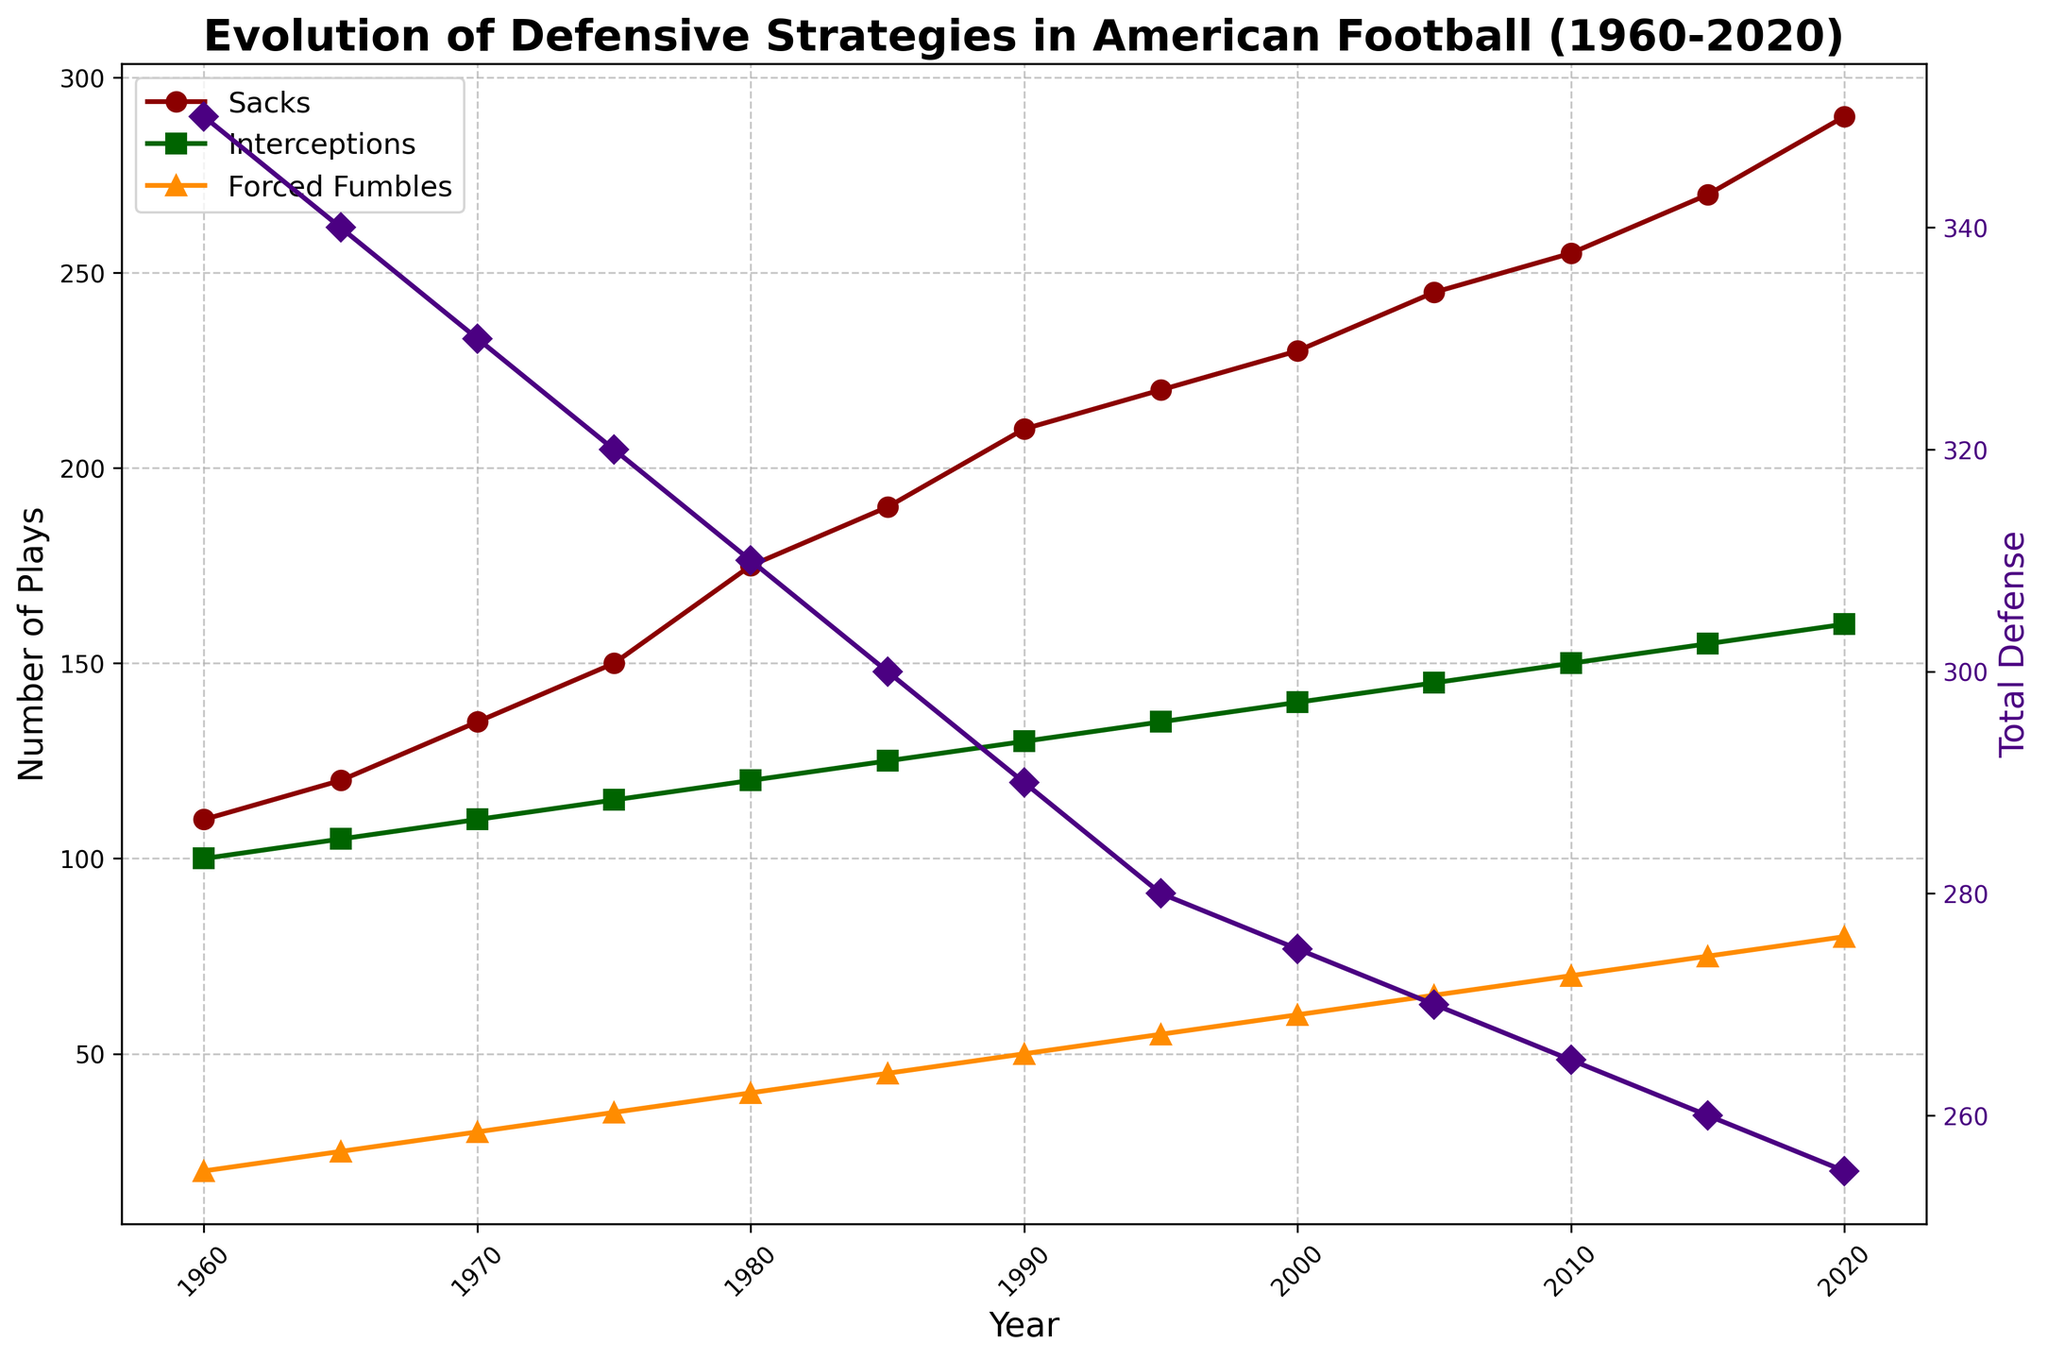What is the title of the figure? The title is displayed at the top of the figure in bold text. It provides an overview of what the figure represents.
Answer: Evolution of Defensive Strategies in American Football (1960-2020) What are the units of measurement on the y-axis? The y-axis labels indicate the units of measurement, which are displayed as 'Number of Plays' and 'Total Defense' on the left and right y-axes, respectively.
Answer: Number of Plays and Total Defense How many data points are plotted for Sacks? By counting the number of markers (circles) on the plot for the Sacks line, one can determine the number of data points.
Answer: 13 Between which years was the most significant increase in Sacks observed? By visually inspecting the Sacks line, the steepest incline can be identified. The largest increase in Sacks happens between the years where the markers are farthest apart vertically.
Answer: 1965-1970 What is the general trend in Forced Fumbles from 1960 to 2020? By following the line for Forced Fumbles from left to right, one can observe whether the line mostly rises, falls, or stays constant.
Answer: Increasing In which year did both Interceptions and Total Defense peak simultaneously? By examining both the line for Interceptions and the secondary y-axis line for Total Defense, one can find the year where high points overlap.
Answer: 2020 How does the trend in Yards Allowed compare to Total Defense over the years? Compare the overall direction of the Yards Allowed line to the direction of the Total Defense line, noting any similarities or differences. Both lines should exhibit opposing trends due to their inverse relationship.
Answer: Decreasing vs. Decreasing What is the difference in the number of Sacks between 1960 and 2020? Subtract the value on the Sacks line in 1960 from the value in 2020.
Answer: 180 Which metric showed the least variation from 1960 to 2020: Sacks, Interceptions, or Forced Fumbles? Gauge the overall spread by looking at the vertical range of each metric line. The metric with the smallest range has the least variation.
Answer: Interceptions What yearly intervals are used on the x-axis? By looking at the years labeled on the x-axis, one can determine the frequency of the tick marks.
Answer: Every 5 years 